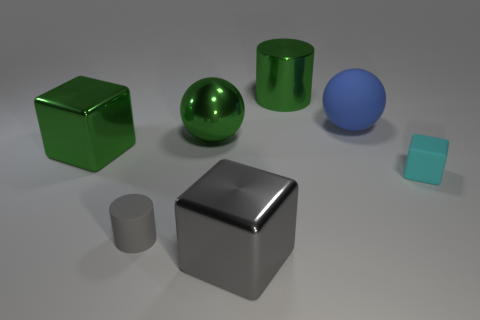Add 1 green metallic cubes. How many objects exist? 8 Subtract all green blocks. How many blocks are left? 2 Subtract all blue balls. How many balls are left? 1 Subtract all spheres. How many objects are left? 5 Subtract all cyan balls. Subtract all brown cylinders. How many balls are left? 2 Subtract all small blue shiny things. Subtract all blue rubber objects. How many objects are left? 6 Add 3 big spheres. How many big spheres are left? 5 Add 1 yellow shiny things. How many yellow shiny things exist? 1 Subtract 1 blue balls. How many objects are left? 6 